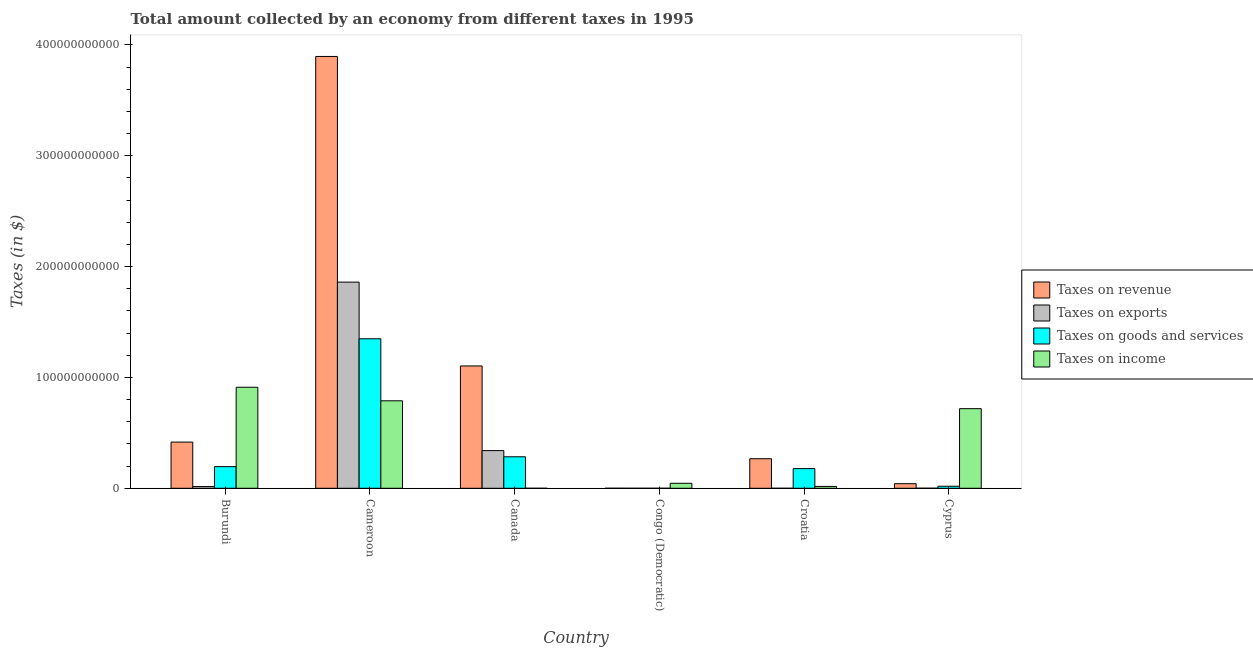How many different coloured bars are there?
Give a very brief answer. 4. How many groups of bars are there?
Make the answer very short. 6. Are the number of bars on each tick of the X-axis equal?
Offer a terse response. Yes. How many bars are there on the 4th tick from the left?
Provide a short and direct response. 4. How many bars are there on the 5th tick from the right?
Keep it short and to the point. 4. What is the label of the 4th group of bars from the left?
Give a very brief answer. Congo (Democratic). What is the amount collected as tax on income in Burundi?
Offer a terse response. 9.12e+1. Across all countries, what is the maximum amount collected as tax on exports?
Provide a short and direct response. 1.86e+11. Across all countries, what is the minimum amount collected as tax on revenue?
Provide a succinct answer. 1.96e+07. In which country was the amount collected as tax on goods maximum?
Keep it short and to the point. Cameroon. In which country was the amount collected as tax on income minimum?
Your answer should be compact. Canada. What is the total amount collected as tax on revenue in the graph?
Ensure brevity in your answer.  5.72e+11. What is the difference between the amount collected as tax on income in Congo (Democratic) and that in Cyprus?
Give a very brief answer. -6.73e+1. What is the difference between the amount collected as tax on revenue in Canada and the amount collected as tax on exports in Cameroon?
Keep it short and to the point. -7.56e+1. What is the average amount collected as tax on revenue per country?
Provide a short and direct response. 9.54e+1. What is the difference between the amount collected as tax on exports and amount collected as tax on income in Burundi?
Your answer should be compact. -8.96e+1. In how many countries, is the amount collected as tax on exports greater than 280000000000 $?
Make the answer very short. 0. What is the ratio of the amount collected as tax on revenue in Burundi to that in Canada?
Keep it short and to the point. 0.38. What is the difference between the highest and the second highest amount collected as tax on revenue?
Make the answer very short. 2.79e+11. What is the difference between the highest and the lowest amount collected as tax on revenue?
Provide a short and direct response. 3.90e+11. In how many countries, is the amount collected as tax on goods greater than the average amount collected as tax on goods taken over all countries?
Your answer should be very brief. 1. Is the sum of the amount collected as tax on income in Burundi and Cyprus greater than the maximum amount collected as tax on exports across all countries?
Your answer should be compact. No. Is it the case that in every country, the sum of the amount collected as tax on goods and amount collected as tax on revenue is greater than the sum of amount collected as tax on income and amount collected as tax on exports?
Provide a short and direct response. No. What does the 4th bar from the left in Cameroon represents?
Make the answer very short. Taxes on income. What does the 2nd bar from the right in Congo (Democratic) represents?
Make the answer very short. Taxes on goods and services. Is it the case that in every country, the sum of the amount collected as tax on revenue and amount collected as tax on exports is greater than the amount collected as tax on goods?
Your answer should be compact. Yes. How many countries are there in the graph?
Offer a terse response. 6. What is the difference between two consecutive major ticks on the Y-axis?
Your answer should be compact. 1.00e+11. Does the graph contain any zero values?
Your answer should be compact. No. How many legend labels are there?
Offer a terse response. 4. How are the legend labels stacked?
Offer a very short reply. Vertical. What is the title of the graph?
Ensure brevity in your answer.  Total amount collected by an economy from different taxes in 1995. Does "Quality Certification" appear as one of the legend labels in the graph?
Ensure brevity in your answer.  No. What is the label or title of the Y-axis?
Offer a very short reply. Taxes (in $). What is the Taxes (in $) of Taxes on revenue in Burundi?
Offer a terse response. 4.17e+1. What is the Taxes (in $) of Taxes on exports in Burundi?
Ensure brevity in your answer.  1.55e+09. What is the Taxes (in $) in Taxes on goods and services in Burundi?
Make the answer very short. 1.95e+1. What is the Taxes (in $) in Taxes on income in Burundi?
Keep it short and to the point. 9.12e+1. What is the Taxes (in $) of Taxes on revenue in Cameroon?
Offer a terse response. 3.90e+11. What is the Taxes (in $) of Taxes on exports in Cameroon?
Ensure brevity in your answer.  1.86e+11. What is the Taxes (in $) of Taxes on goods and services in Cameroon?
Offer a terse response. 1.35e+11. What is the Taxes (in $) in Taxes on income in Cameroon?
Offer a very short reply. 7.89e+1. What is the Taxes (in $) of Taxes on revenue in Canada?
Make the answer very short. 1.10e+11. What is the Taxes (in $) in Taxes on exports in Canada?
Your answer should be compact. 3.40e+1. What is the Taxes (in $) of Taxes on goods and services in Canada?
Offer a terse response. 2.84e+1. What is the Taxes (in $) in Taxes on revenue in Congo (Democratic)?
Provide a succinct answer. 1.96e+07. What is the Taxes (in $) of Taxes on exports in Congo (Democratic)?
Your answer should be very brief. 3.00e+06. What is the Taxes (in $) in Taxes on goods and services in Congo (Democratic)?
Give a very brief answer. 3.96e+06. What is the Taxes (in $) of Taxes on income in Congo (Democratic)?
Your answer should be compact. 4.51e+09. What is the Taxes (in $) in Taxes on revenue in Croatia?
Your answer should be compact. 2.67e+1. What is the Taxes (in $) of Taxes on exports in Croatia?
Keep it short and to the point. 1.40e+06. What is the Taxes (in $) in Taxes on goods and services in Croatia?
Offer a terse response. 1.77e+1. What is the Taxes (in $) in Taxes on income in Croatia?
Give a very brief answer. 1.67e+09. What is the Taxes (in $) of Taxes on revenue in Cyprus?
Offer a terse response. 4.13e+09. What is the Taxes (in $) in Taxes on exports in Cyprus?
Keep it short and to the point. 6.30e+07. What is the Taxes (in $) of Taxes on goods and services in Cyprus?
Keep it short and to the point. 1.83e+09. What is the Taxes (in $) in Taxes on income in Cyprus?
Keep it short and to the point. 7.18e+1. Across all countries, what is the maximum Taxes (in $) in Taxes on revenue?
Make the answer very short. 3.90e+11. Across all countries, what is the maximum Taxes (in $) of Taxes on exports?
Provide a short and direct response. 1.86e+11. Across all countries, what is the maximum Taxes (in $) in Taxes on goods and services?
Make the answer very short. 1.35e+11. Across all countries, what is the maximum Taxes (in $) in Taxes on income?
Give a very brief answer. 9.12e+1. Across all countries, what is the minimum Taxes (in $) in Taxes on revenue?
Ensure brevity in your answer.  1.96e+07. Across all countries, what is the minimum Taxes (in $) in Taxes on exports?
Your response must be concise. 1.40e+06. Across all countries, what is the minimum Taxes (in $) in Taxes on goods and services?
Provide a succinct answer. 3.96e+06. What is the total Taxes (in $) in Taxes on revenue in the graph?
Your answer should be compact. 5.72e+11. What is the total Taxes (in $) of Taxes on exports in the graph?
Ensure brevity in your answer.  2.22e+11. What is the total Taxes (in $) of Taxes on goods and services in the graph?
Your answer should be very brief. 2.02e+11. What is the total Taxes (in $) in Taxes on income in the graph?
Ensure brevity in your answer.  2.48e+11. What is the difference between the Taxes (in $) in Taxes on revenue in Burundi and that in Cameroon?
Offer a terse response. -3.48e+11. What is the difference between the Taxes (in $) of Taxes on exports in Burundi and that in Cameroon?
Your answer should be very brief. -1.84e+11. What is the difference between the Taxes (in $) of Taxes on goods and services in Burundi and that in Cameroon?
Ensure brevity in your answer.  -1.15e+11. What is the difference between the Taxes (in $) of Taxes on income in Burundi and that in Cameroon?
Ensure brevity in your answer.  1.22e+1. What is the difference between the Taxes (in $) in Taxes on revenue in Burundi and that in Canada?
Your answer should be very brief. -6.87e+1. What is the difference between the Taxes (in $) of Taxes on exports in Burundi and that in Canada?
Your answer should be compact. -3.24e+1. What is the difference between the Taxes (in $) of Taxes on goods and services in Burundi and that in Canada?
Your response must be concise. -8.90e+09. What is the difference between the Taxes (in $) in Taxes on income in Burundi and that in Canada?
Make the answer very short. 9.11e+1. What is the difference between the Taxes (in $) in Taxes on revenue in Burundi and that in Congo (Democratic)?
Offer a very short reply. 4.17e+1. What is the difference between the Taxes (in $) of Taxes on exports in Burundi and that in Congo (Democratic)?
Your response must be concise. 1.55e+09. What is the difference between the Taxes (in $) of Taxes on goods and services in Burundi and that in Congo (Democratic)?
Make the answer very short. 1.95e+1. What is the difference between the Taxes (in $) in Taxes on income in Burundi and that in Congo (Democratic)?
Make the answer very short. 8.66e+1. What is the difference between the Taxes (in $) in Taxes on revenue in Burundi and that in Croatia?
Offer a very short reply. 1.50e+1. What is the difference between the Taxes (in $) of Taxes on exports in Burundi and that in Croatia?
Provide a succinct answer. 1.55e+09. What is the difference between the Taxes (in $) of Taxes on goods and services in Burundi and that in Croatia?
Give a very brief answer. 1.77e+09. What is the difference between the Taxes (in $) of Taxes on income in Burundi and that in Croatia?
Give a very brief answer. 8.95e+1. What is the difference between the Taxes (in $) in Taxes on revenue in Burundi and that in Cyprus?
Offer a terse response. 3.75e+1. What is the difference between the Taxes (in $) in Taxes on exports in Burundi and that in Cyprus?
Ensure brevity in your answer.  1.49e+09. What is the difference between the Taxes (in $) of Taxes on goods and services in Burundi and that in Cyprus?
Make the answer very short. 1.77e+1. What is the difference between the Taxes (in $) in Taxes on income in Burundi and that in Cyprus?
Your response must be concise. 1.93e+1. What is the difference between the Taxes (in $) in Taxes on revenue in Cameroon and that in Canada?
Offer a terse response. 2.79e+11. What is the difference between the Taxes (in $) of Taxes on exports in Cameroon and that in Canada?
Provide a succinct answer. 1.52e+11. What is the difference between the Taxes (in $) of Taxes on goods and services in Cameroon and that in Canada?
Give a very brief answer. 1.06e+11. What is the difference between the Taxes (in $) in Taxes on income in Cameroon and that in Canada?
Offer a terse response. 7.89e+1. What is the difference between the Taxes (in $) in Taxes on revenue in Cameroon and that in Congo (Democratic)?
Your response must be concise. 3.90e+11. What is the difference between the Taxes (in $) of Taxes on exports in Cameroon and that in Congo (Democratic)?
Offer a very short reply. 1.86e+11. What is the difference between the Taxes (in $) in Taxes on goods and services in Cameroon and that in Congo (Democratic)?
Ensure brevity in your answer.  1.35e+11. What is the difference between the Taxes (in $) in Taxes on income in Cameroon and that in Congo (Democratic)?
Your response must be concise. 7.44e+1. What is the difference between the Taxes (in $) in Taxes on revenue in Cameroon and that in Croatia?
Provide a succinct answer. 3.63e+11. What is the difference between the Taxes (in $) in Taxes on exports in Cameroon and that in Croatia?
Give a very brief answer. 1.86e+11. What is the difference between the Taxes (in $) in Taxes on goods and services in Cameroon and that in Croatia?
Give a very brief answer. 1.17e+11. What is the difference between the Taxes (in $) in Taxes on income in Cameroon and that in Croatia?
Provide a short and direct response. 7.72e+1. What is the difference between the Taxes (in $) of Taxes on revenue in Cameroon and that in Cyprus?
Offer a terse response. 3.85e+11. What is the difference between the Taxes (in $) in Taxes on exports in Cameroon and that in Cyprus?
Ensure brevity in your answer.  1.86e+11. What is the difference between the Taxes (in $) of Taxes on goods and services in Cameroon and that in Cyprus?
Your answer should be very brief. 1.33e+11. What is the difference between the Taxes (in $) of Taxes on income in Cameroon and that in Cyprus?
Offer a terse response. 7.09e+09. What is the difference between the Taxes (in $) of Taxes on revenue in Canada and that in Congo (Democratic)?
Provide a succinct answer. 1.10e+11. What is the difference between the Taxes (in $) of Taxes on exports in Canada and that in Congo (Democratic)?
Give a very brief answer. 3.40e+1. What is the difference between the Taxes (in $) of Taxes on goods and services in Canada and that in Congo (Democratic)?
Give a very brief answer. 2.84e+1. What is the difference between the Taxes (in $) of Taxes on income in Canada and that in Congo (Democratic)?
Ensure brevity in your answer.  -4.50e+09. What is the difference between the Taxes (in $) of Taxes on revenue in Canada and that in Croatia?
Keep it short and to the point. 8.37e+1. What is the difference between the Taxes (in $) in Taxes on exports in Canada and that in Croatia?
Your answer should be compact. 3.40e+1. What is the difference between the Taxes (in $) of Taxes on goods and services in Canada and that in Croatia?
Offer a very short reply. 1.07e+1. What is the difference between the Taxes (in $) of Taxes on income in Canada and that in Croatia?
Ensure brevity in your answer.  -1.67e+09. What is the difference between the Taxes (in $) in Taxes on revenue in Canada and that in Cyprus?
Your response must be concise. 1.06e+11. What is the difference between the Taxes (in $) of Taxes on exports in Canada and that in Cyprus?
Offer a very short reply. 3.39e+1. What is the difference between the Taxes (in $) in Taxes on goods and services in Canada and that in Cyprus?
Provide a succinct answer. 2.66e+1. What is the difference between the Taxes (in $) of Taxes on income in Canada and that in Cyprus?
Offer a terse response. -7.18e+1. What is the difference between the Taxes (in $) in Taxes on revenue in Congo (Democratic) and that in Croatia?
Offer a very short reply. -2.67e+1. What is the difference between the Taxes (in $) in Taxes on exports in Congo (Democratic) and that in Croatia?
Make the answer very short. 1.60e+06. What is the difference between the Taxes (in $) in Taxes on goods and services in Congo (Democratic) and that in Croatia?
Give a very brief answer. -1.77e+1. What is the difference between the Taxes (in $) in Taxes on income in Congo (Democratic) and that in Croatia?
Make the answer very short. 2.83e+09. What is the difference between the Taxes (in $) of Taxes on revenue in Congo (Democratic) and that in Cyprus?
Keep it short and to the point. -4.11e+09. What is the difference between the Taxes (in $) in Taxes on exports in Congo (Democratic) and that in Cyprus?
Make the answer very short. -6.00e+07. What is the difference between the Taxes (in $) of Taxes on goods and services in Congo (Democratic) and that in Cyprus?
Provide a short and direct response. -1.83e+09. What is the difference between the Taxes (in $) in Taxes on income in Congo (Democratic) and that in Cyprus?
Ensure brevity in your answer.  -6.73e+1. What is the difference between the Taxes (in $) in Taxes on revenue in Croatia and that in Cyprus?
Your answer should be very brief. 2.25e+1. What is the difference between the Taxes (in $) in Taxes on exports in Croatia and that in Cyprus?
Keep it short and to the point. -6.16e+07. What is the difference between the Taxes (in $) in Taxes on goods and services in Croatia and that in Cyprus?
Your answer should be compact. 1.59e+1. What is the difference between the Taxes (in $) in Taxes on income in Croatia and that in Cyprus?
Make the answer very short. -7.02e+1. What is the difference between the Taxes (in $) in Taxes on revenue in Burundi and the Taxes (in $) in Taxes on exports in Cameroon?
Keep it short and to the point. -1.44e+11. What is the difference between the Taxes (in $) in Taxes on revenue in Burundi and the Taxes (in $) in Taxes on goods and services in Cameroon?
Keep it short and to the point. -9.32e+1. What is the difference between the Taxes (in $) in Taxes on revenue in Burundi and the Taxes (in $) in Taxes on income in Cameroon?
Provide a short and direct response. -3.72e+1. What is the difference between the Taxes (in $) of Taxes on exports in Burundi and the Taxes (in $) of Taxes on goods and services in Cameroon?
Give a very brief answer. -1.33e+11. What is the difference between the Taxes (in $) in Taxes on exports in Burundi and the Taxes (in $) in Taxes on income in Cameroon?
Offer a very short reply. -7.74e+1. What is the difference between the Taxes (in $) in Taxes on goods and services in Burundi and the Taxes (in $) in Taxes on income in Cameroon?
Offer a terse response. -5.94e+1. What is the difference between the Taxes (in $) of Taxes on revenue in Burundi and the Taxes (in $) of Taxes on exports in Canada?
Offer a terse response. 7.67e+09. What is the difference between the Taxes (in $) of Taxes on revenue in Burundi and the Taxes (in $) of Taxes on goods and services in Canada?
Keep it short and to the point. 1.33e+1. What is the difference between the Taxes (in $) of Taxes on revenue in Burundi and the Taxes (in $) of Taxes on income in Canada?
Your answer should be very brief. 4.17e+1. What is the difference between the Taxes (in $) in Taxes on exports in Burundi and the Taxes (in $) in Taxes on goods and services in Canada?
Offer a terse response. -2.69e+1. What is the difference between the Taxes (in $) of Taxes on exports in Burundi and the Taxes (in $) of Taxes on income in Canada?
Ensure brevity in your answer.  1.54e+09. What is the difference between the Taxes (in $) of Taxes on goods and services in Burundi and the Taxes (in $) of Taxes on income in Canada?
Your response must be concise. 1.95e+1. What is the difference between the Taxes (in $) of Taxes on revenue in Burundi and the Taxes (in $) of Taxes on exports in Congo (Democratic)?
Offer a terse response. 4.17e+1. What is the difference between the Taxes (in $) in Taxes on revenue in Burundi and the Taxes (in $) in Taxes on goods and services in Congo (Democratic)?
Your answer should be compact. 4.17e+1. What is the difference between the Taxes (in $) in Taxes on revenue in Burundi and the Taxes (in $) in Taxes on income in Congo (Democratic)?
Make the answer very short. 3.72e+1. What is the difference between the Taxes (in $) of Taxes on exports in Burundi and the Taxes (in $) of Taxes on goods and services in Congo (Democratic)?
Your answer should be very brief. 1.55e+09. What is the difference between the Taxes (in $) of Taxes on exports in Burundi and the Taxes (in $) of Taxes on income in Congo (Democratic)?
Offer a terse response. -2.96e+09. What is the difference between the Taxes (in $) in Taxes on goods and services in Burundi and the Taxes (in $) in Taxes on income in Congo (Democratic)?
Provide a short and direct response. 1.50e+1. What is the difference between the Taxes (in $) in Taxes on revenue in Burundi and the Taxes (in $) in Taxes on exports in Croatia?
Make the answer very short. 4.17e+1. What is the difference between the Taxes (in $) in Taxes on revenue in Burundi and the Taxes (in $) in Taxes on goods and services in Croatia?
Your response must be concise. 2.39e+1. What is the difference between the Taxes (in $) in Taxes on revenue in Burundi and the Taxes (in $) in Taxes on income in Croatia?
Keep it short and to the point. 4.00e+1. What is the difference between the Taxes (in $) in Taxes on exports in Burundi and the Taxes (in $) in Taxes on goods and services in Croatia?
Offer a very short reply. -1.62e+1. What is the difference between the Taxes (in $) in Taxes on exports in Burundi and the Taxes (in $) in Taxes on income in Croatia?
Offer a very short reply. -1.24e+08. What is the difference between the Taxes (in $) of Taxes on goods and services in Burundi and the Taxes (in $) of Taxes on income in Croatia?
Provide a succinct answer. 1.78e+1. What is the difference between the Taxes (in $) of Taxes on revenue in Burundi and the Taxes (in $) of Taxes on exports in Cyprus?
Make the answer very short. 4.16e+1. What is the difference between the Taxes (in $) in Taxes on revenue in Burundi and the Taxes (in $) in Taxes on goods and services in Cyprus?
Ensure brevity in your answer.  3.98e+1. What is the difference between the Taxes (in $) in Taxes on revenue in Burundi and the Taxes (in $) in Taxes on income in Cyprus?
Provide a succinct answer. -3.02e+1. What is the difference between the Taxes (in $) in Taxes on exports in Burundi and the Taxes (in $) in Taxes on goods and services in Cyprus?
Give a very brief answer. -2.82e+08. What is the difference between the Taxes (in $) in Taxes on exports in Burundi and the Taxes (in $) in Taxes on income in Cyprus?
Make the answer very short. -7.03e+1. What is the difference between the Taxes (in $) in Taxes on goods and services in Burundi and the Taxes (in $) in Taxes on income in Cyprus?
Offer a very short reply. -5.23e+1. What is the difference between the Taxes (in $) of Taxes on revenue in Cameroon and the Taxes (in $) of Taxes on exports in Canada?
Your answer should be compact. 3.56e+11. What is the difference between the Taxes (in $) in Taxes on revenue in Cameroon and the Taxes (in $) in Taxes on goods and services in Canada?
Ensure brevity in your answer.  3.61e+11. What is the difference between the Taxes (in $) in Taxes on revenue in Cameroon and the Taxes (in $) in Taxes on income in Canada?
Keep it short and to the point. 3.90e+11. What is the difference between the Taxes (in $) in Taxes on exports in Cameroon and the Taxes (in $) in Taxes on goods and services in Canada?
Your response must be concise. 1.58e+11. What is the difference between the Taxes (in $) of Taxes on exports in Cameroon and the Taxes (in $) of Taxes on income in Canada?
Your answer should be very brief. 1.86e+11. What is the difference between the Taxes (in $) of Taxes on goods and services in Cameroon and the Taxes (in $) of Taxes on income in Canada?
Your answer should be very brief. 1.35e+11. What is the difference between the Taxes (in $) of Taxes on revenue in Cameroon and the Taxes (in $) of Taxes on exports in Congo (Democratic)?
Provide a succinct answer. 3.90e+11. What is the difference between the Taxes (in $) of Taxes on revenue in Cameroon and the Taxes (in $) of Taxes on goods and services in Congo (Democratic)?
Give a very brief answer. 3.90e+11. What is the difference between the Taxes (in $) of Taxes on revenue in Cameroon and the Taxes (in $) of Taxes on income in Congo (Democratic)?
Ensure brevity in your answer.  3.85e+11. What is the difference between the Taxes (in $) of Taxes on exports in Cameroon and the Taxes (in $) of Taxes on goods and services in Congo (Democratic)?
Ensure brevity in your answer.  1.86e+11. What is the difference between the Taxes (in $) in Taxes on exports in Cameroon and the Taxes (in $) in Taxes on income in Congo (Democratic)?
Your answer should be very brief. 1.81e+11. What is the difference between the Taxes (in $) in Taxes on goods and services in Cameroon and the Taxes (in $) in Taxes on income in Congo (Democratic)?
Your answer should be compact. 1.30e+11. What is the difference between the Taxes (in $) of Taxes on revenue in Cameroon and the Taxes (in $) of Taxes on exports in Croatia?
Your response must be concise. 3.90e+11. What is the difference between the Taxes (in $) of Taxes on revenue in Cameroon and the Taxes (in $) of Taxes on goods and services in Croatia?
Your response must be concise. 3.72e+11. What is the difference between the Taxes (in $) of Taxes on revenue in Cameroon and the Taxes (in $) of Taxes on income in Croatia?
Provide a short and direct response. 3.88e+11. What is the difference between the Taxes (in $) of Taxes on exports in Cameroon and the Taxes (in $) of Taxes on goods and services in Croatia?
Ensure brevity in your answer.  1.68e+11. What is the difference between the Taxes (in $) in Taxes on exports in Cameroon and the Taxes (in $) in Taxes on income in Croatia?
Keep it short and to the point. 1.84e+11. What is the difference between the Taxes (in $) in Taxes on goods and services in Cameroon and the Taxes (in $) in Taxes on income in Croatia?
Offer a terse response. 1.33e+11. What is the difference between the Taxes (in $) in Taxes on revenue in Cameroon and the Taxes (in $) in Taxes on exports in Cyprus?
Offer a terse response. 3.90e+11. What is the difference between the Taxes (in $) of Taxes on revenue in Cameroon and the Taxes (in $) of Taxes on goods and services in Cyprus?
Provide a succinct answer. 3.88e+11. What is the difference between the Taxes (in $) of Taxes on revenue in Cameroon and the Taxes (in $) of Taxes on income in Cyprus?
Provide a succinct answer. 3.18e+11. What is the difference between the Taxes (in $) in Taxes on exports in Cameroon and the Taxes (in $) in Taxes on goods and services in Cyprus?
Offer a very short reply. 1.84e+11. What is the difference between the Taxes (in $) in Taxes on exports in Cameroon and the Taxes (in $) in Taxes on income in Cyprus?
Provide a short and direct response. 1.14e+11. What is the difference between the Taxes (in $) of Taxes on goods and services in Cameroon and the Taxes (in $) of Taxes on income in Cyprus?
Your answer should be compact. 6.31e+1. What is the difference between the Taxes (in $) in Taxes on revenue in Canada and the Taxes (in $) in Taxes on exports in Congo (Democratic)?
Ensure brevity in your answer.  1.10e+11. What is the difference between the Taxes (in $) of Taxes on revenue in Canada and the Taxes (in $) of Taxes on goods and services in Congo (Democratic)?
Your answer should be compact. 1.10e+11. What is the difference between the Taxes (in $) of Taxes on revenue in Canada and the Taxes (in $) of Taxes on income in Congo (Democratic)?
Offer a terse response. 1.06e+11. What is the difference between the Taxes (in $) of Taxes on exports in Canada and the Taxes (in $) of Taxes on goods and services in Congo (Democratic)?
Make the answer very short. 3.40e+1. What is the difference between the Taxes (in $) in Taxes on exports in Canada and the Taxes (in $) in Taxes on income in Congo (Democratic)?
Your answer should be very brief. 2.95e+1. What is the difference between the Taxes (in $) in Taxes on goods and services in Canada and the Taxes (in $) in Taxes on income in Congo (Democratic)?
Provide a succinct answer. 2.39e+1. What is the difference between the Taxes (in $) in Taxes on revenue in Canada and the Taxes (in $) in Taxes on exports in Croatia?
Your response must be concise. 1.10e+11. What is the difference between the Taxes (in $) of Taxes on revenue in Canada and the Taxes (in $) of Taxes on goods and services in Croatia?
Your response must be concise. 9.26e+1. What is the difference between the Taxes (in $) in Taxes on revenue in Canada and the Taxes (in $) in Taxes on income in Croatia?
Keep it short and to the point. 1.09e+11. What is the difference between the Taxes (in $) in Taxes on exports in Canada and the Taxes (in $) in Taxes on goods and services in Croatia?
Give a very brief answer. 1.63e+1. What is the difference between the Taxes (in $) of Taxes on exports in Canada and the Taxes (in $) of Taxes on income in Croatia?
Offer a very short reply. 3.23e+1. What is the difference between the Taxes (in $) in Taxes on goods and services in Canada and the Taxes (in $) in Taxes on income in Croatia?
Provide a succinct answer. 2.67e+1. What is the difference between the Taxes (in $) of Taxes on revenue in Canada and the Taxes (in $) of Taxes on exports in Cyprus?
Give a very brief answer. 1.10e+11. What is the difference between the Taxes (in $) in Taxes on revenue in Canada and the Taxes (in $) in Taxes on goods and services in Cyprus?
Offer a terse response. 1.09e+11. What is the difference between the Taxes (in $) of Taxes on revenue in Canada and the Taxes (in $) of Taxes on income in Cyprus?
Ensure brevity in your answer.  3.85e+1. What is the difference between the Taxes (in $) of Taxes on exports in Canada and the Taxes (in $) of Taxes on goods and services in Cyprus?
Your answer should be very brief. 3.22e+1. What is the difference between the Taxes (in $) of Taxes on exports in Canada and the Taxes (in $) of Taxes on income in Cyprus?
Offer a terse response. -3.78e+1. What is the difference between the Taxes (in $) of Taxes on goods and services in Canada and the Taxes (in $) of Taxes on income in Cyprus?
Your answer should be compact. -4.34e+1. What is the difference between the Taxes (in $) of Taxes on revenue in Congo (Democratic) and the Taxes (in $) of Taxes on exports in Croatia?
Ensure brevity in your answer.  1.82e+07. What is the difference between the Taxes (in $) in Taxes on revenue in Congo (Democratic) and the Taxes (in $) in Taxes on goods and services in Croatia?
Your answer should be compact. -1.77e+1. What is the difference between the Taxes (in $) in Taxes on revenue in Congo (Democratic) and the Taxes (in $) in Taxes on income in Croatia?
Ensure brevity in your answer.  -1.65e+09. What is the difference between the Taxes (in $) in Taxes on exports in Congo (Democratic) and the Taxes (in $) in Taxes on goods and services in Croatia?
Provide a short and direct response. -1.77e+1. What is the difference between the Taxes (in $) in Taxes on exports in Congo (Democratic) and the Taxes (in $) in Taxes on income in Croatia?
Ensure brevity in your answer.  -1.67e+09. What is the difference between the Taxes (in $) in Taxes on goods and services in Congo (Democratic) and the Taxes (in $) in Taxes on income in Croatia?
Keep it short and to the point. -1.67e+09. What is the difference between the Taxes (in $) in Taxes on revenue in Congo (Democratic) and the Taxes (in $) in Taxes on exports in Cyprus?
Your answer should be very brief. -4.34e+07. What is the difference between the Taxes (in $) in Taxes on revenue in Congo (Democratic) and the Taxes (in $) in Taxes on goods and services in Cyprus?
Your answer should be very brief. -1.81e+09. What is the difference between the Taxes (in $) of Taxes on revenue in Congo (Democratic) and the Taxes (in $) of Taxes on income in Cyprus?
Your response must be concise. -7.18e+1. What is the difference between the Taxes (in $) of Taxes on exports in Congo (Democratic) and the Taxes (in $) of Taxes on goods and services in Cyprus?
Your response must be concise. -1.83e+09. What is the difference between the Taxes (in $) in Taxes on exports in Congo (Democratic) and the Taxes (in $) in Taxes on income in Cyprus?
Make the answer very short. -7.18e+1. What is the difference between the Taxes (in $) of Taxes on goods and services in Congo (Democratic) and the Taxes (in $) of Taxes on income in Cyprus?
Your answer should be very brief. -7.18e+1. What is the difference between the Taxes (in $) in Taxes on revenue in Croatia and the Taxes (in $) in Taxes on exports in Cyprus?
Your answer should be very brief. 2.66e+1. What is the difference between the Taxes (in $) of Taxes on revenue in Croatia and the Taxes (in $) of Taxes on goods and services in Cyprus?
Your answer should be very brief. 2.48e+1. What is the difference between the Taxes (in $) in Taxes on revenue in Croatia and the Taxes (in $) in Taxes on income in Cyprus?
Keep it short and to the point. -4.51e+1. What is the difference between the Taxes (in $) of Taxes on exports in Croatia and the Taxes (in $) of Taxes on goods and services in Cyprus?
Offer a terse response. -1.83e+09. What is the difference between the Taxes (in $) in Taxes on exports in Croatia and the Taxes (in $) in Taxes on income in Cyprus?
Provide a succinct answer. -7.18e+1. What is the difference between the Taxes (in $) in Taxes on goods and services in Croatia and the Taxes (in $) in Taxes on income in Cyprus?
Your answer should be very brief. -5.41e+1. What is the average Taxes (in $) of Taxes on revenue per country?
Provide a short and direct response. 9.54e+1. What is the average Taxes (in $) in Taxes on exports per country?
Your response must be concise. 3.69e+1. What is the average Taxes (in $) in Taxes on goods and services per country?
Your answer should be very brief. 3.37e+1. What is the average Taxes (in $) of Taxes on income per country?
Your answer should be very brief. 4.13e+1. What is the difference between the Taxes (in $) of Taxes on revenue and Taxes (in $) of Taxes on exports in Burundi?
Offer a terse response. 4.01e+1. What is the difference between the Taxes (in $) of Taxes on revenue and Taxes (in $) of Taxes on goods and services in Burundi?
Offer a very short reply. 2.22e+1. What is the difference between the Taxes (in $) in Taxes on revenue and Taxes (in $) in Taxes on income in Burundi?
Your answer should be compact. -4.95e+1. What is the difference between the Taxes (in $) of Taxes on exports and Taxes (in $) of Taxes on goods and services in Burundi?
Provide a succinct answer. -1.80e+1. What is the difference between the Taxes (in $) of Taxes on exports and Taxes (in $) of Taxes on income in Burundi?
Give a very brief answer. -8.96e+1. What is the difference between the Taxes (in $) of Taxes on goods and services and Taxes (in $) of Taxes on income in Burundi?
Provide a short and direct response. -7.16e+1. What is the difference between the Taxes (in $) of Taxes on revenue and Taxes (in $) of Taxes on exports in Cameroon?
Your response must be concise. 2.04e+11. What is the difference between the Taxes (in $) of Taxes on revenue and Taxes (in $) of Taxes on goods and services in Cameroon?
Provide a short and direct response. 2.55e+11. What is the difference between the Taxes (in $) in Taxes on revenue and Taxes (in $) in Taxes on income in Cameroon?
Offer a terse response. 3.11e+11. What is the difference between the Taxes (in $) in Taxes on exports and Taxes (in $) in Taxes on goods and services in Cameroon?
Keep it short and to the point. 5.11e+1. What is the difference between the Taxes (in $) of Taxes on exports and Taxes (in $) of Taxes on income in Cameroon?
Your answer should be compact. 1.07e+11. What is the difference between the Taxes (in $) of Taxes on goods and services and Taxes (in $) of Taxes on income in Cameroon?
Make the answer very short. 5.60e+1. What is the difference between the Taxes (in $) of Taxes on revenue and Taxes (in $) of Taxes on exports in Canada?
Keep it short and to the point. 7.64e+1. What is the difference between the Taxes (in $) in Taxes on revenue and Taxes (in $) in Taxes on goods and services in Canada?
Keep it short and to the point. 8.20e+1. What is the difference between the Taxes (in $) in Taxes on revenue and Taxes (in $) in Taxes on income in Canada?
Offer a very short reply. 1.10e+11. What is the difference between the Taxes (in $) in Taxes on exports and Taxes (in $) in Taxes on goods and services in Canada?
Your response must be concise. 5.59e+09. What is the difference between the Taxes (in $) in Taxes on exports and Taxes (in $) in Taxes on income in Canada?
Give a very brief answer. 3.40e+1. What is the difference between the Taxes (in $) in Taxes on goods and services and Taxes (in $) in Taxes on income in Canada?
Make the answer very short. 2.84e+1. What is the difference between the Taxes (in $) of Taxes on revenue and Taxes (in $) of Taxes on exports in Congo (Democratic)?
Your response must be concise. 1.66e+07. What is the difference between the Taxes (in $) of Taxes on revenue and Taxes (in $) of Taxes on goods and services in Congo (Democratic)?
Provide a short and direct response. 1.56e+07. What is the difference between the Taxes (in $) of Taxes on revenue and Taxes (in $) of Taxes on income in Congo (Democratic)?
Provide a succinct answer. -4.49e+09. What is the difference between the Taxes (in $) of Taxes on exports and Taxes (in $) of Taxes on goods and services in Congo (Democratic)?
Offer a terse response. -9.60e+05. What is the difference between the Taxes (in $) of Taxes on exports and Taxes (in $) of Taxes on income in Congo (Democratic)?
Offer a terse response. -4.50e+09. What is the difference between the Taxes (in $) in Taxes on goods and services and Taxes (in $) in Taxes on income in Congo (Democratic)?
Offer a very short reply. -4.50e+09. What is the difference between the Taxes (in $) in Taxes on revenue and Taxes (in $) in Taxes on exports in Croatia?
Your response must be concise. 2.67e+1. What is the difference between the Taxes (in $) of Taxes on revenue and Taxes (in $) of Taxes on goods and services in Croatia?
Offer a terse response. 8.93e+09. What is the difference between the Taxes (in $) of Taxes on revenue and Taxes (in $) of Taxes on income in Croatia?
Your response must be concise. 2.50e+1. What is the difference between the Taxes (in $) in Taxes on exports and Taxes (in $) in Taxes on goods and services in Croatia?
Keep it short and to the point. -1.77e+1. What is the difference between the Taxes (in $) of Taxes on exports and Taxes (in $) of Taxes on income in Croatia?
Offer a very short reply. -1.67e+09. What is the difference between the Taxes (in $) of Taxes on goods and services and Taxes (in $) of Taxes on income in Croatia?
Offer a very short reply. 1.61e+1. What is the difference between the Taxes (in $) of Taxes on revenue and Taxes (in $) of Taxes on exports in Cyprus?
Keep it short and to the point. 4.07e+09. What is the difference between the Taxes (in $) in Taxes on revenue and Taxes (in $) in Taxes on goods and services in Cyprus?
Offer a terse response. 2.30e+09. What is the difference between the Taxes (in $) in Taxes on revenue and Taxes (in $) in Taxes on income in Cyprus?
Provide a short and direct response. -6.77e+1. What is the difference between the Taxes (in $) in Taxes on exports and Taxes (in $) in Taxes on goods and services in Cyprus?
Provide a short and direct response. -1.77e+09. What is the difference between the Taxes (in $) in Taxes on exports and Taxes (in $) in Taxes on income in Cyprus?
Provide a short and direct response. -7.18e+1. What is the difference between the Taxes (in $) of Taxes on goods and services and Taxes (in $) of Taxes on income in Cyprus?
Your answer should be very brief. -7.00e+1. What is the ratio of the Taxes (in $) in Taxes on revenue in Burundi to that in Cameroon?
Give a very brief answer. 0.11. What is the ratio of the Taxes (in $) of Taxes on exports in Burundi to that in Cameroon?
Make the answer very short. 0.01. What is the ratio of the Taxes (in $) of Taxes on goods and services in Burundi to that in Cameroon?
Provide a succinct answer. 0.14. What is the ratio of the Taxes (in $) of Taxes on income in Burundi to that in Cameroon?
Keep it short and to the point. 1.16. What is the ratio of the Taxes (in $) of Taxes on revenue in Burundi to that in Canada?
Keep it short and to the point. 0.38. What is the ratio of the Taxes (in $) in Taxes on exports in Burundi to that in Canada?
Make the answer very short. 0.05. What is the ratio of the Taxes (in $) in Taxes on goods and services in Burundi to that in Canada?
Offer a terse response. 0.69. What is the ratio of the Taxes (in $) in Taxes on income in Burundi to that in Canada?
Keep it short and to the point. 1.30e+04. What is the ratio of the Taxes (in $) of Taxes on revenue in Burundi to that in Congo (Democratic)?
Offer a terse response. 2131.61. What is the ratio of the Taxes (in $) of Taxes on exports in Burundi to that in Congo (Democratic)?
Your answer should be very brief. 516.67. What is the ratio of the Taxes (in $) in Taxes on goods and services in Burundi to that in Congo (Democratic)?
Your answer should be very brief. 4927.27. What is the ratio of the Taxes (in $) of Taxes on income in Burundi to that in Congo (Democratic)?
Provide a short and direct response. 20.23. What is the ratio of the Taxes (in $) of Taxes on revenue in Burundi to that in Croatia?
Keep it short and to the point. 1.56. What is the ratio of the Taxes (in $) in Taxes on exports in Burundi to that in Croatia?
Provide a short and direct response. 1107.14. What is the ratio of the Taxes (in $) of Taxes on goods and services in Burundi to that in Croatia?
Offer a very short reply. 1.1. What is the ratio of the Taxes (in $) in Taxes on income in Burundi to that in Croatia?
Your answer should be compact. 54.44. What is the ratio of the Taxes (in $) of Taxes on revenue in Burundi to that in Cyprus?
Make the answer very short. 10.08. What is the ratio of the Taxes (in $) of Taxes on exports in Burundi to that in Cyprus?
Keep it short and to the point. 24.6. What is the ratio of the Taxes (in $) of Taxes on goods and services in Burundi to that in Cyprus?
Offer a very short reply. 10.65. What is the ratio of the Taxes (in $) of Taxes on income in Burundi to that in Cyprus?
Provide a short and direct response. 1.27. What is the ratio of the Taxes (in $) of Taxes on revenue in Cameroon to that in Canada?
Provide a succinct answer. 3.53. What is the ratio of the Taxes (in $) of Taxes on exports in Cameroon to that in Canada?
Make the answer very short. 5.47. What is the ratio of the Taxes (in $) of Taxes on goods and services in Cameroon to that in Canada?
Offer a very short reply. 4.75. What is the ratio of the Taxes (in $) in Taxes on income in Cameroon to that in Canada?
Offer a terse response. 1.13e+04. What is the ratio of the Taxes (in $) in Taxes on revenue in Cameroon to that in Congo (Democratic)?
Give a very brief answer. 1.99e+04. What is the ratio of the Taxes (in $) in Taxes on exports in Cameroon to that in Congo (Democratic)?
Your answer should be compact. 6.20e+04. What is the ratio of the Taxes (in $) of Taxes on goods and services in Cameroon to that in Congo (Democratic)?
Ensure brevity in your answer.  3.41e+04. What is the ratio of the Taxes (in $) in Taxes on income in Cameroon to that in Congo (Democratic)?
Your answer should be very brief. 17.51. What is the ratio of the Taxes (in $) of Taxes on revenue in Cameroon to that in Croatia?
Provide a short and direct response. 14.6. What is the ratio of the Taxes (in $) in Taxes on exports in Cameroon to that in Croatia?
Keep it short and to the point. 1.33e+05. What is the ratio of the Taxes (in $) in Taxes on goods and services in Cameroon to that in Croatia?
Make the answer very short. 7.6. What is the ratio of the Taxes (in $) of Taxes on income in Cameroon to that in Croatia?
Your response must be concise. 47.14. What is the ratio of the Taxes (in $) in Taxes on revenue in Cameroon to that in Cyprus?
Your answer should be very brief. 94.27. What is the ratio of the Taxes (in $) of Taxes on exports in Cameroon to that in Cyprus?
Keep it short and to the point. 2952.38. What is the ratio of the Taxes (in $) of Taxes on goods and services in Cameroon to that in Cyprus?
Provide a succinct answer. 73.61. What is the ratio of the Taxes (in $) of Taxes on income in Cameroon to that in Cyprus?
Your response must be concise. 1.1. What is the ratio of the Taxes (in $) in Taxes on revenue in Canada to that in Congo (Democratic)?
Give a very brief answer. 5645.42. What is the ratio of the Taxes (in $) of Taxes on exports in Canada to that in Congo (Democratic)?
Keep it short and to the point. 1.13e+04. What is the ratio of the Taxes (in $) of Taxes on goods and services in Canada to that in Congo (Democratic)?
Keep it short and to the point. 7174.24. What is the ratio of the Taxes (in $) in Taxes on income in Canada to that in Congo (Democratic)?
Your answer should be compact. 0. What is the ratio of the Taxes (in $) of Taxes on revenue in Canada to that in Croatia?
Provide a short and direct response. 4.14. What is the ratio of the Taxes (in $) in Taxes on exports in Canada to that in Croatia?
Provide a succinct answer. 2.43e+04. What is the ratio of the Taxes (in $) of Taxes on goods and services in Canada to that in Croatia?
Keep it short and to the point. 1.6. What is the ratio of the Taxes (in $) of Taxes on income in Canada to that in Croatia?
Keep it short and to the point. 0. What is the ratio of the Taxes (in $) in Taxes on revenue in Canada to that in Cyprus?
Provide a succinct answer. 26.71. What is the ratio of the Taxes (in $) in Taxes on exports in Canada to that in Cyprus?
Provide a succinct answer. 539.68. What is the ratio of the Taxes (in $) in Taxes on goods and services in Canada to that in Cyprus?
Provide a short and direct response. 15.5. What is the ratio of the Taxes (in $) of Taxes on revenue in Congo (Democratic) to that in Croatia?
Make the answer very short. 0. What is the ratio of the Taxes (in $) in Taxes on exports in Congo (Democratic) to that in Croatia?
Provide a succinct answer. 2.14. What is the ratio of the Taxes (in $) of Taxes on income in Congo (Democratic) to that in Croatia?
Your answer should be very brief. 2.69. What is the ratio of the Taxes (in $) in Taxes on revenue in Congo (Democratic) to that in Cyprus?
Keep it short and to the point. 0. What is the ratio of the Taxes (in $) in Taxes on exports in Congo (Democratic) to that in Cyprus?
Offer a very short reply. 0.05. What is the ratio of the Taxes (in $) in Taxes on goods and services in Congo (Democratic) to that in Cyprus?
Your answer should be very brief. 0. What is the ratio of the Taxes (in $) of Taxes on income in Congo (Democratic) to that in Cyprus?
Offer a very short reply. 0.06. What is the ratio of the Taxes (in $) in Taxes on revenue in Croatia to that in Cyprus?
Ensure brevity in your answer.  6.46. What is the ratio of the Taxes (in $) in Taxes on exports in Croatia to that in Cyprus?
Give a very brief answer. 0.02. What is the ratio of the Taxes (in $) in Taxes on goods and services in Croatia to that in Cyprus?
Provide a succinct answer. 9.68. What is the ratio of the Taxes (in $) in Taxes on income in Croatia to that in Cyprus?
Provide a succinct answer. 0.02. What is the difference between the highest and the second highest Taxes (in $) in Taxes on revenue?
Keep it short and to the point. 2.79e+11. What is the difference between the highest and the second highest Taxes (in $) in Taxes on exports?
Your response must be concise. 1.52e+11. What is the difference between the highest and the second highest Taxes (in $) in Taxes on goods and services?
Your answer should be very brief. 1.06e+11. What is the difference between the highest and the second highest Taxes (in $) in Taxes on income?
Ensure brevity in your answer.  1.22e+1. What is the difference between the highest and the lowest Taxes (in $) in Taxes on revenue?
Give a very brief answer. 3.90e+11. What is the difference between the highest and the lowest Taxes (in $) of Taxes on exports?
Your answer should be very brief. 1.86e+11. What is the difference between the highest and the lowest Taxes (in $) in Taxes on goods and services?
Ensure brevity in your answer.  1.35e+11. What is the difference between the highest and the lowest Taxes (in $) of Taxes on income?
Provide a succinct answer. 9.11e+1. 